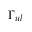<formula> <loc_0><loc_0><loc_500><loc_500>\Gamma _ { u l }</formula> 